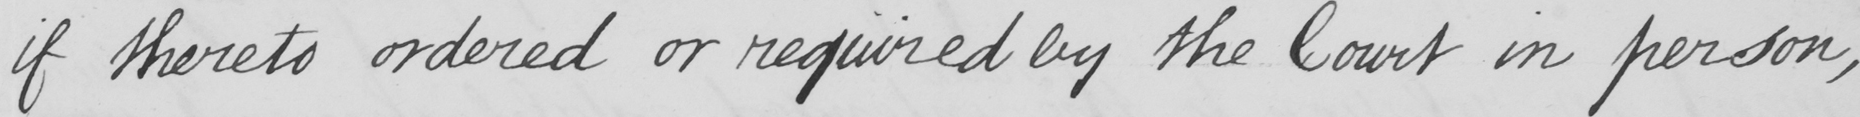Transcribe the text shown in this historical manuscript line. if thereto ordered or required by the Court in person , 